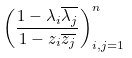Convert formula to latex. <formula><loc_0><loc_0><loc_500><loc_500>\left ( \frac { 1 - \lambda _ { i } \overline { \lambda _ { j } } } { 1 - z _ { i } \overline { z _ { j } } } \right ) _ { i , j = 1 } ^ { n }</formula> 